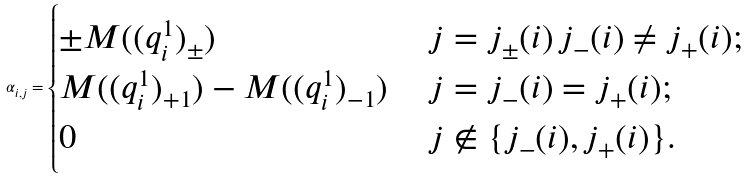<formula> <loc_0><loc_0><loc_500><loc_500>\alpha _ { i , j } = \begin{cases} \pm M ( ( q _ { i } ^ { 1 } ) _ { \pm } ) & \, j = j _ { \pm } ( i ) \, j _ { - } ( i ) \not = j _ { + } ( i ) ; \\ M ( ( q _ { i } ^ { 1 } ) _ { + 1 } ) - M ( ( q _ { i } ^ { 1 } ) _ { - 1 } ) & \, j = j _ { - } ( i ) = j _ { + } ( i ) ; \\ 0 & \, j \notin \{ j _ { - } ( i ) , j _ { + } ( i ) \} . \end{cases}</formula> 